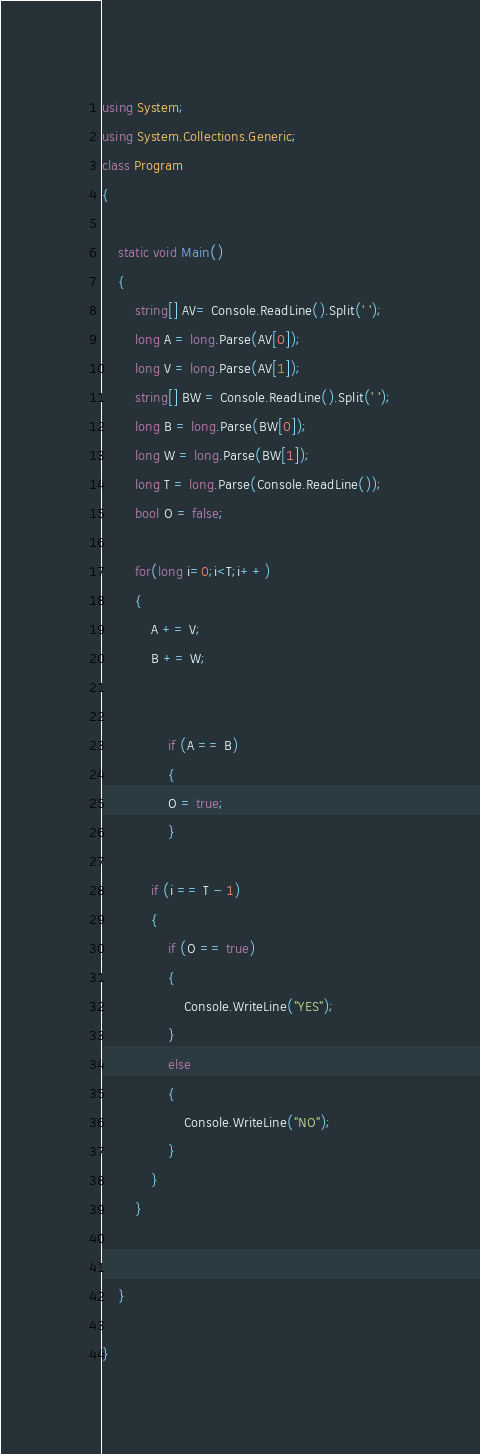<code> <loc_0><loc_0><loc_500><loc_500><_C#_>using System;
using System.Collections.Generic;
class Program
{

    static void Main()
    {
        string[] AV= Console.ReadLine().Split(' ');
        long A = long.Parse(AV[0]);
        long V = long.Parse(AV[1]);
        string[] BW = Console.ReadLine().Split(' ');
        long B = long.Parse(BW[0]);
        long W = long.Parse(BW[1]);
        long T = long.Parse(Console.ReadLine());
        bool O = false;

        for(long i=0;i<T;i++)
        {
            A += V;
            B += W;

            
                if (A == B)
                {
                O = true;
                }

            if (i == T - 1)
            {
                if (O == true)
                {
                    Console.WriteLine("YES");
                }
                else
                {
                    Console.WriteLine("NO");
                }
            }
        }


    }

}</code> 